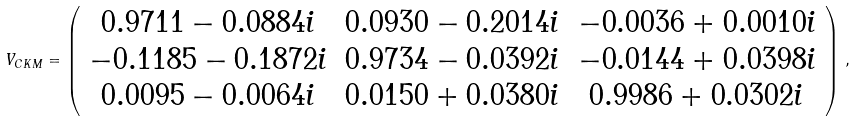Convert formula to latex. <formula><loc_0><loc_0><loc_500><loc_500>V _ { C K M } = \left ( \begin{array} { c c c } 0 . 9 7 1 1 - 0 . 0 8 8 4 i & 0 . 0 9 3 0 - 0 . 2 0 1 4 i & - 0 . 0 0 3 6 + 0 . 0 0 1 0 i \\ - 0 . 1 1 8 5 - 0 . 1 8 7 2 i & 0 . 9 7 3 4 - 0 . 0 3 9 2 i & - 0 . 0 1 4 4 + 0 . 0 3 9 8 i \\ 0 . 0 0 9 5 - 0 . 0 0 6 4 i & 0 . 0 1 5 0 + 0 . 0 3 8 0 i & 0 . 9 9 8 6 + 0 . 0 3 0 2 i \end{array} \right ) \, ,</formula> 